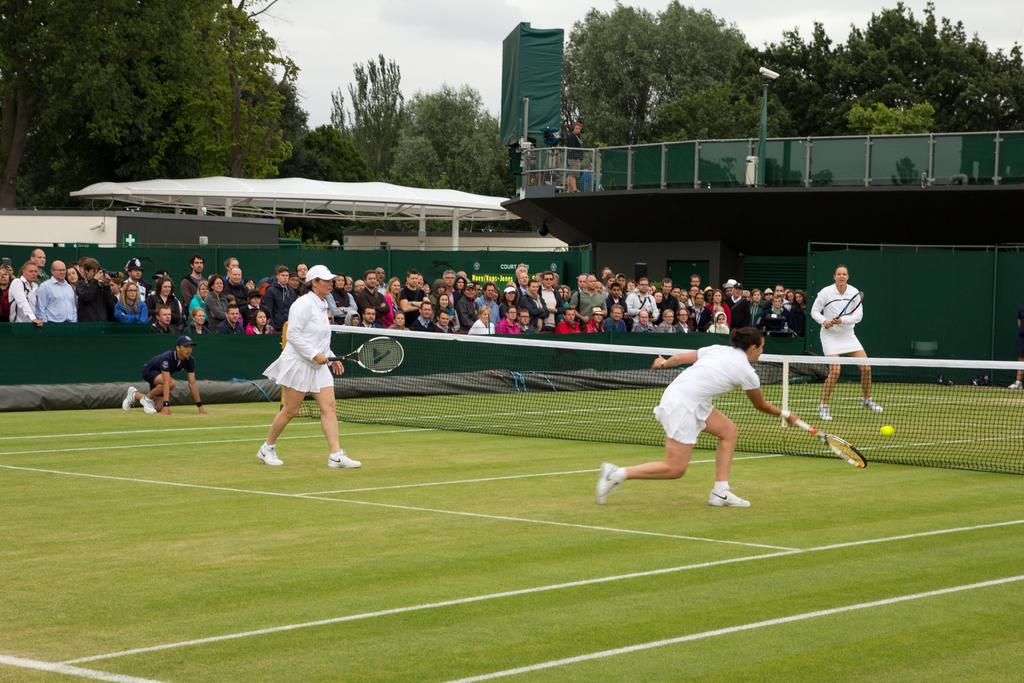What activity are the people in the image engaged in? People are playing badminton in the image. What can be seen in the background of the image? There are trees, sheds, lights, and a crowd in the background of the image. What type of skin condition can be seen on the players in the image? There is no indication of any skin condition on the players in the image. How many beds are visible in the image? There are no beds present in the image. 